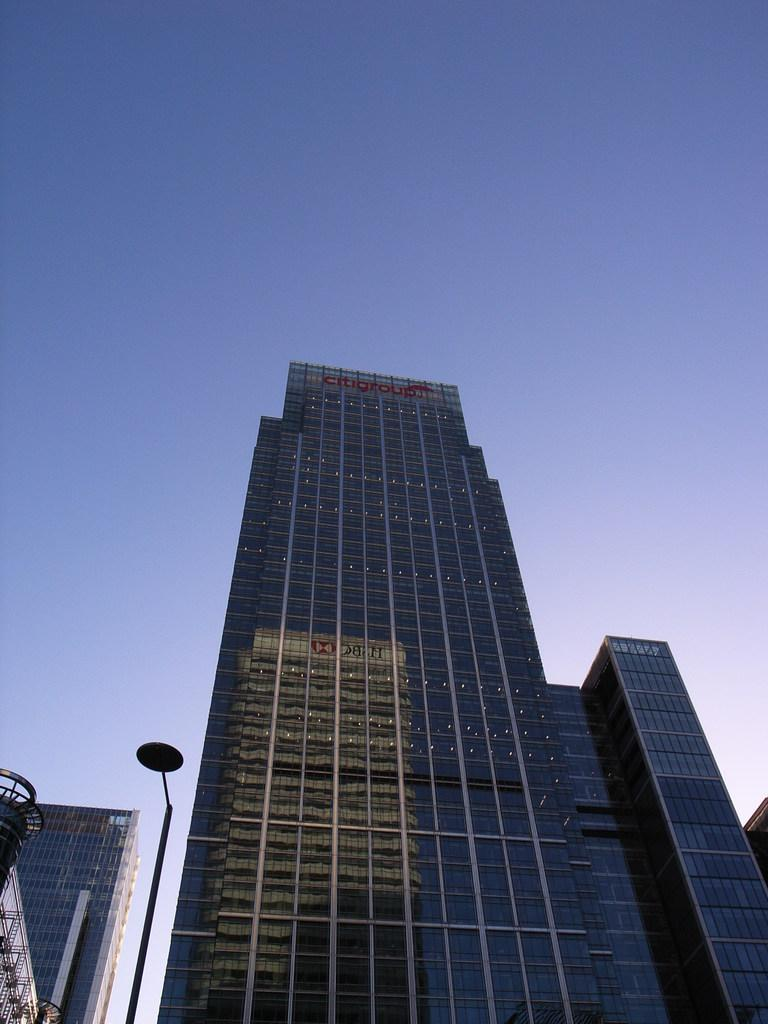What type of structures can be seen in the image? There are buildings in the image. Can you describe any other objects in the image besides the buildings? Yes, there is a pole in the image. What type of cracker is being used as a canvas for the spot in the image? There is no cracker or spot present in the image. 